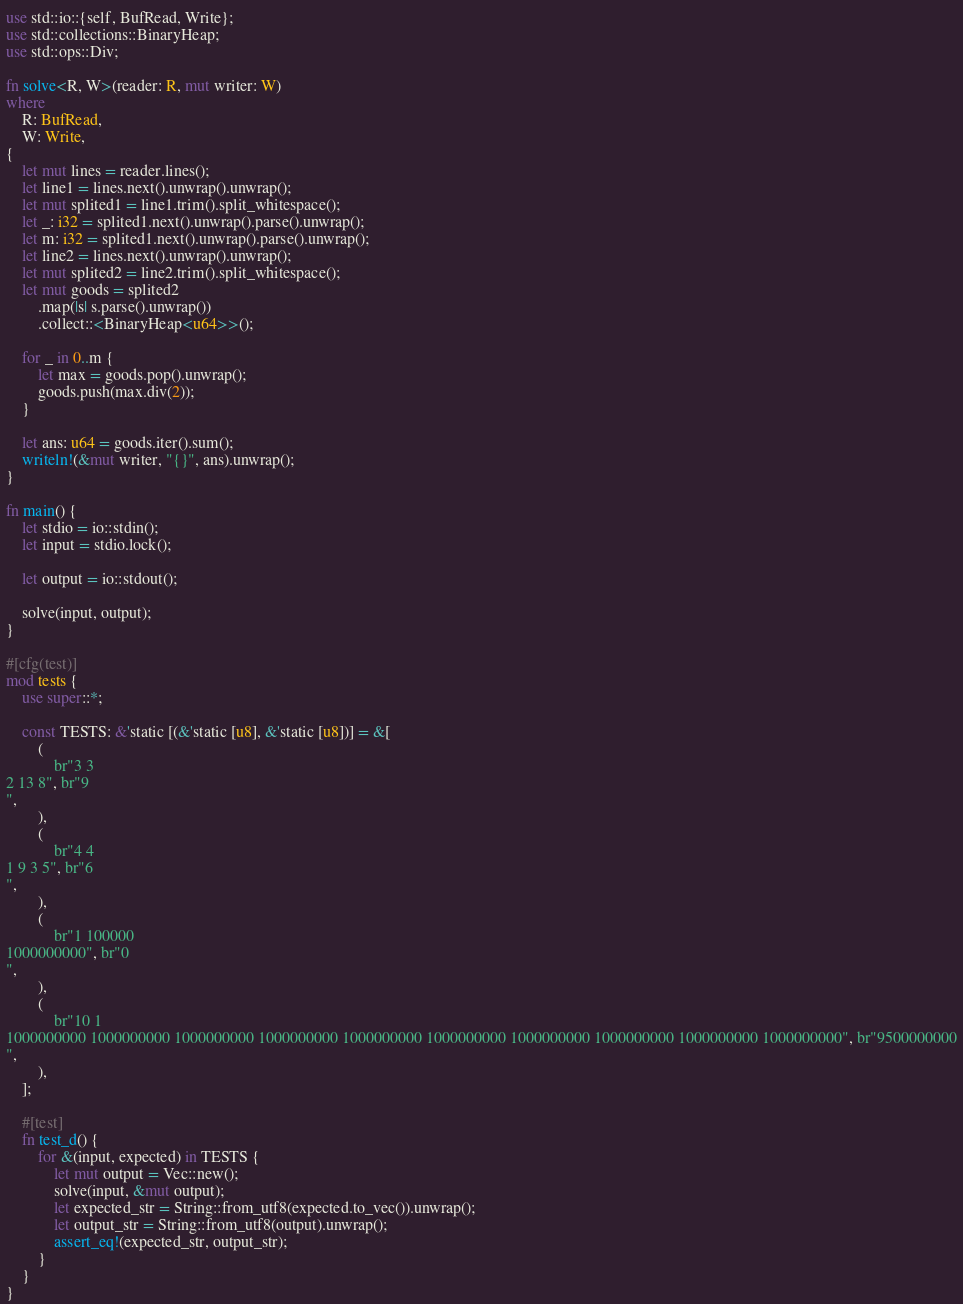<code> <loc_0><loc_0><loc_500><loc_500><_Rust_>use std::io::{self, BufRead, Write};
use std::collections::BinaryHeap;
use std::ops::Div;

fn solve<R, W>(reader: R, mut writer: W)
where
    R: BufRead,
    W: Write,
{
    let mut lines = reader.lines();
    let line1 = lines.next().unwrap().unwrap();
    let mut splited1 = line1.trim().split_whitespace();
    let _: i32 = splited1.next().unwrap().parse().unwrap();
    let m: i32 = splited1.next().unwrap().parse().unwrap();
    let line2 = lines.next().unwrap().unwrap();
    let mut splited2 = line2.trim().split_whitespace();
    let mut goods = splited2
        .map(|s| s.parse().unwrap())
        .collect::<BinaryHeap<u64>>();

    for _ in 0..m {
        let max = goods.pop().unwrap();
        goods.push(max.div(2));
    }

    let ans: u64 = goods.iter().sum();
    writeln!(&mut writer, "{}", ans).unwrap();
}

fn main() {
    let stdio = io::stdin();
    let input = stdio.lock();

    let output = io::stdout();

    solve(input, output);
}

#[cfg(test)]
mod tests {
    use super::*;

    const TESTS: &'static [(&'static [u8], &'static [u8])] = &[
        (
            br"3 3
2 13 8", br"9
",
        ),
        (
            br"4 4
1 9 3 5", br"6
",
        ),
        (
            br"1 100000
1000000000", br"0
",
        ),
        (
            br"10 1
1000000000 1000000000 1000000000 1000000000 1000000000 1000000000 1000000000 1000000000 1000000000 1000000000", br"9500000000
",
        ),
    ];

    #[test]
    fn test_d() {
        for &(input, expected) in TESTS {
            let mut output = Vec::new();
            solve(input, &mut output);
            let expected_str = String::from_utf8(expected.to_vec()).unwrap();
            let output_str = String::from_utf8(output).unwrap();
            assert_eq!(expected_str, output_str);
        }
    }
}
</code> 